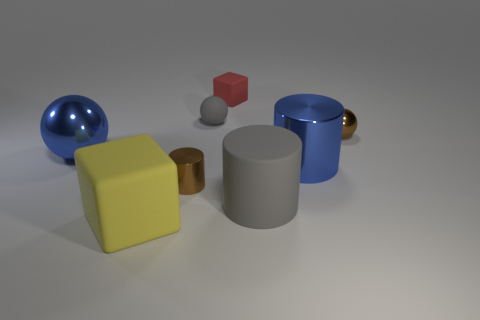Add 1 big gray matte cylinders. How many objects exist? 9 Subtract all cubes. How many objects are left? 6 Add 6 matte spheres. How many matte spheres are left? 7 Add 5 large cylinders. How many large cylinders exist? 7 Subtract 1 gray spheres. How many objects are left? 7 Subtract all red rubber blocks. Subtract all big gray cylinders. How many objects are left? 6 